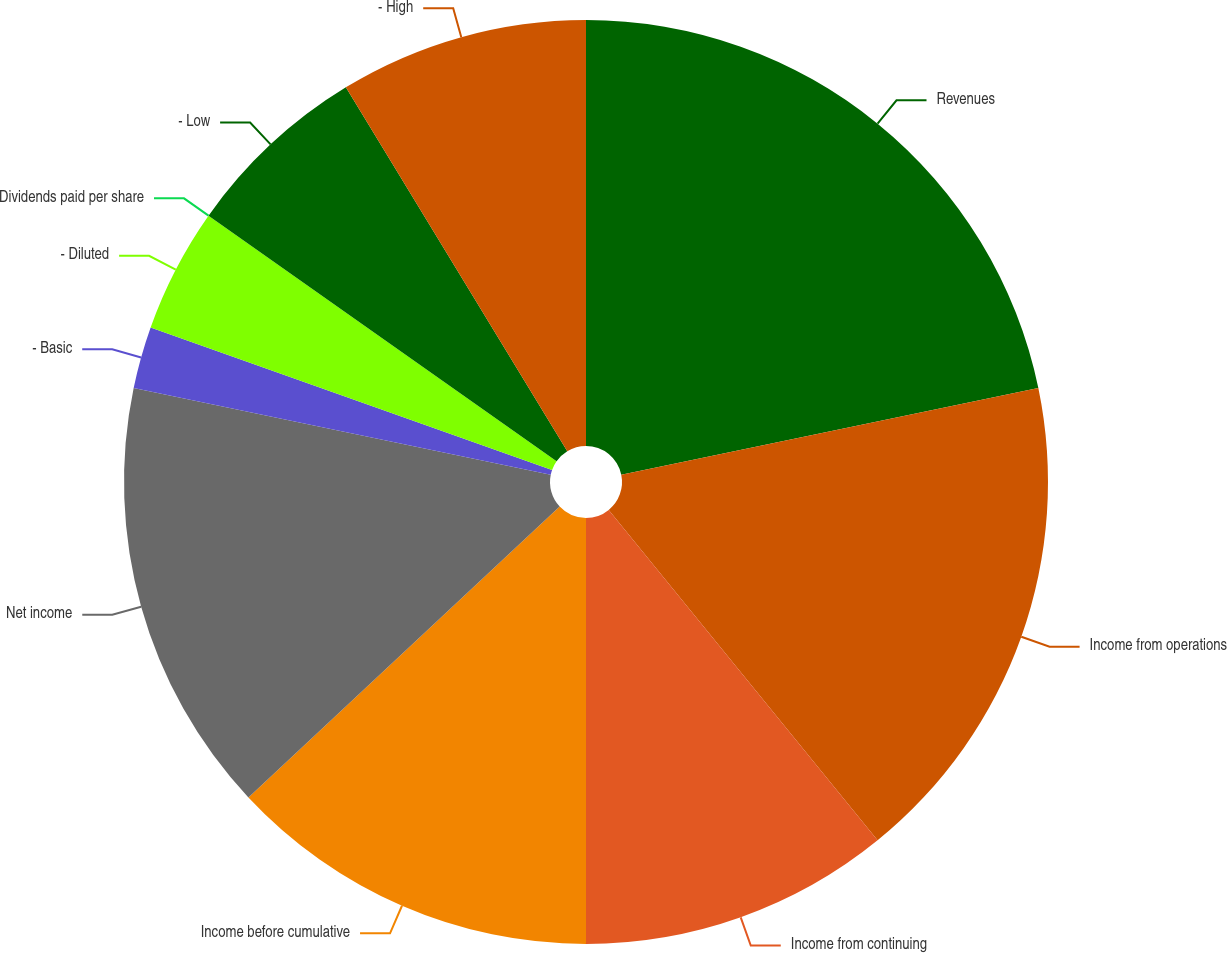<chart> <loc_0><loc_0><loc_500><loc_500><pie_chart><fcel>Revenues<fcel>Income from operations<fcel>Income from continuing<fcel>Income before cumulative<fcel>Net income<fcel>- Basic<fcel>- Diluted<fcel>Dividends paid per share<fcel>- Low<fcel>- High<nl><fcel>21.74%<fcel>17.39%<fcel>10.87%<fcel>13.04%<fcel>15.22%<fcel>2.17%<fcel>4.35%<fcel>0.0%<fcel>6.52%<fcel>8.7%<nl></chart> 